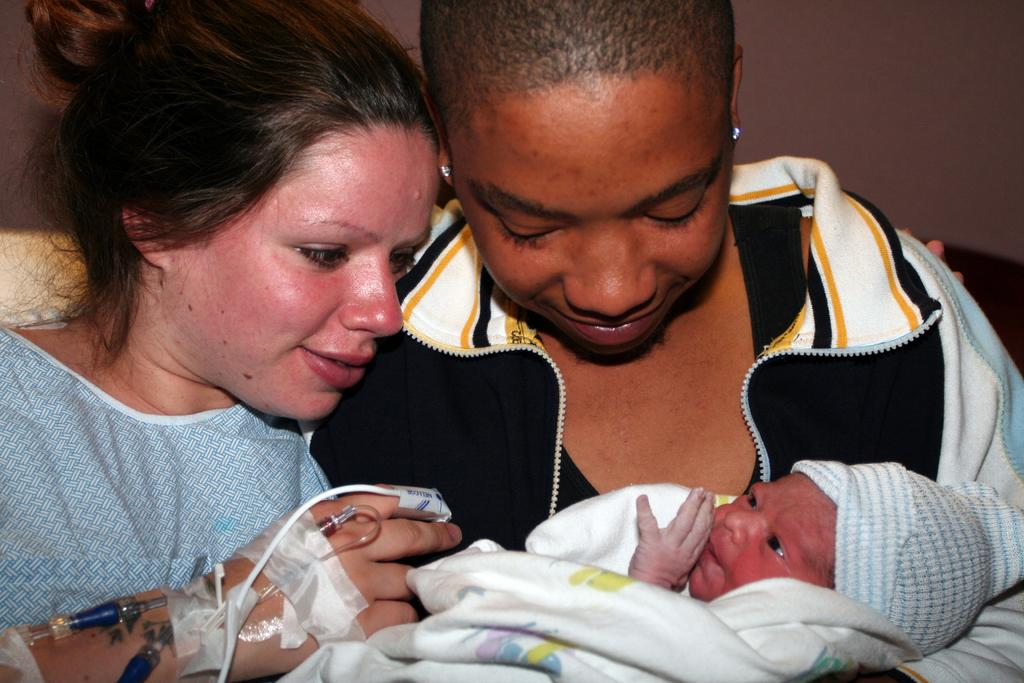How many people are in the image? There are two persons in the image. What are the two persons doing in the image? The two persons are holding a baby. What can be seen in the background of the image? There is a wall visible in the background of the image. What type of bread is being twisted by the baby in the image? There is no bread or twisting action involving the baby in the image. 